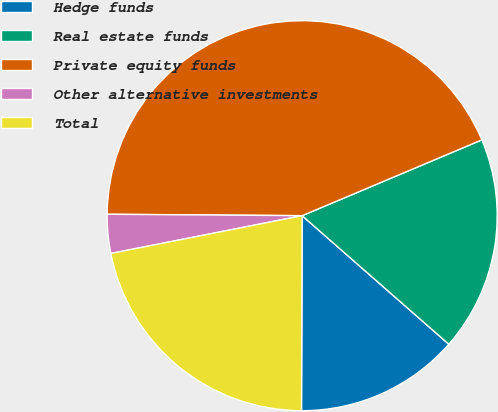Convert chart. <chart><loc_0><loc_0><loc_500><loc_500><pie_chart><fcel>Hedge funds<fcel>Real estate funds<fcel>Private equity funds<fcel>Other alternative investments<fcel>Total<nl><fcel>13.6%<fcel>17.81%<fcel>43.53%<fcel>3.22%<fcel>21.84%<nl></chart> 